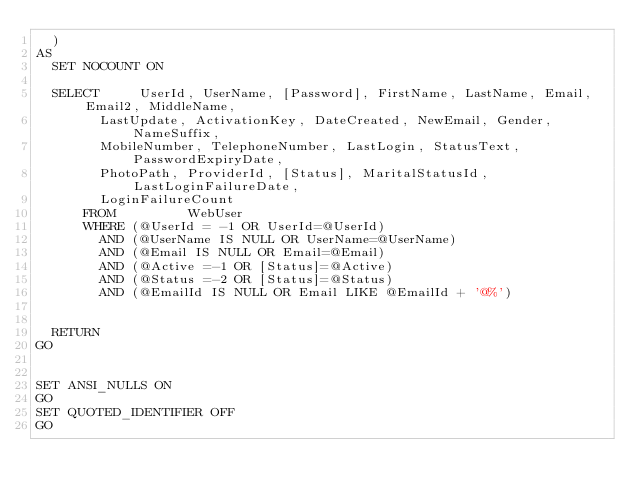Convert code to text. <code><loc_0><loc_0><loc_500><loc_500><_SQL_>	)
AS
	SET NOCOUNT ON
	
	SELECT     UserId, UserName, [Password], FirstName, LastName, Email, Email2, MiddleName,
				LastUpdate, ActivationKey, DateCreated, NewEmail, Gender, NameSuffix,
				MobileNumber, TelephoneNumber, LastLogin, StatusText, PasswordExpiryDate,
				PhotoPath, ProviderId, [Status], MaritalStatusId, LastLoginFailureDate,
				LoginFailureCount
			FROM         WebUser
			WHERE (@UserId = -1 OR UserId=@UserId)
				AND (@UserName IS NULL OR UserName=@UserName)
				AND (@Email IS NULL OR Email=@Email)
				AND (@Active =-1 OR [Status]=@Active)
				AND (@Status =-2 OR [Status]=@Status)
				AND (@EmailId IS NULL OR Email LIKE @EmailId + '@%')
				

	RETURN
GO


SET ANSI_NULLS ON
GO
SET QUOTED_IDENTIFIER OFF
GO

</code> 